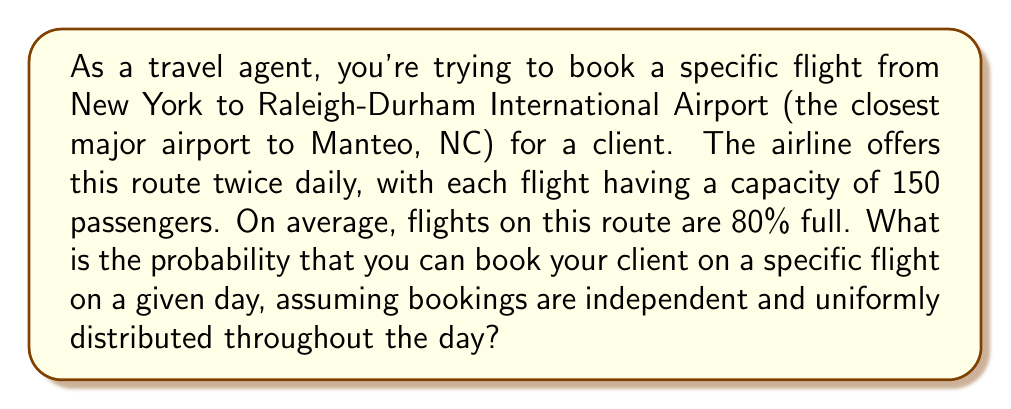Solve this math problem. Let's approach this step-by-step:

1) First, we need to calculate the average number of available seats on each flight:
   
   Total seats = 150
   Average occupancy = 80% = 0.8
   Average available seats = $150 * (1 - 0.8) = 150 * 0.2 = 30$ seats

2) The probability of getting a seat is the number of available seats divided by the total number of seats:

   $P(\text{getting a seat}) = \frac{\text{Available seats}}{\text{Total seats}} = \frac{30}{150} = 0.2$

3) However, this is the average probability. We need to account for the fact that bookings are independent and uniformly distributed.

4) In probability theory, when we have a fixed average rate of occurrences over a period of time, and these occurrences are independent, we can model this using a Poisson distribution.

5) The probability of exactly $k$ successes in a Poisson distribution is given by:

   $P(X = k) = \frac{e^{-\lambda} \lambda^k}{k!}$

   Where $\lambda$ is the average rate of success.

6) In our case, we're interested in the probability of 0 bookings for the remaining 30 seats, as this would leave a seat available for our client.

7) $\lambda = 30 * 0.8 = 24$ (as on average, 80% of the 30 seats get booked)

8) Therefore, the probability of exactly 0 bookings is:

   $P(X = 0) = \frac{e^{-24} 24^0}{0!} = e^{-24} \approx 3.78 * 10^{-11}$

9) This is the probability that all 30 seats remain available. However, we only need one seat for our client. The probability of at least one seat being available is the complement of all seats being taken:

   $P(\text{at least one seat available}) = 1 - P(\text{all seats taken}) = 1 - (1 - e^{-24}) \approx 3.78 * 10^{-11}$
Answer: $3.78 * 10^{-11}$ 